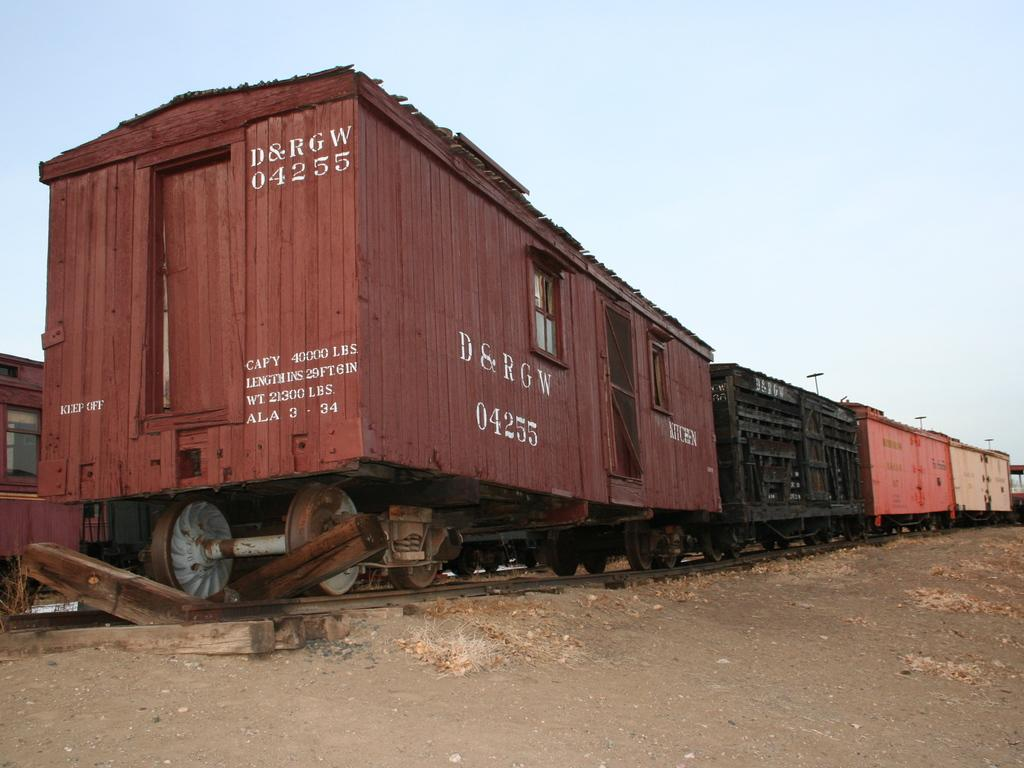<image>
Present a compact description of the photo's key features. the numbers 04255 are on the back of a train 